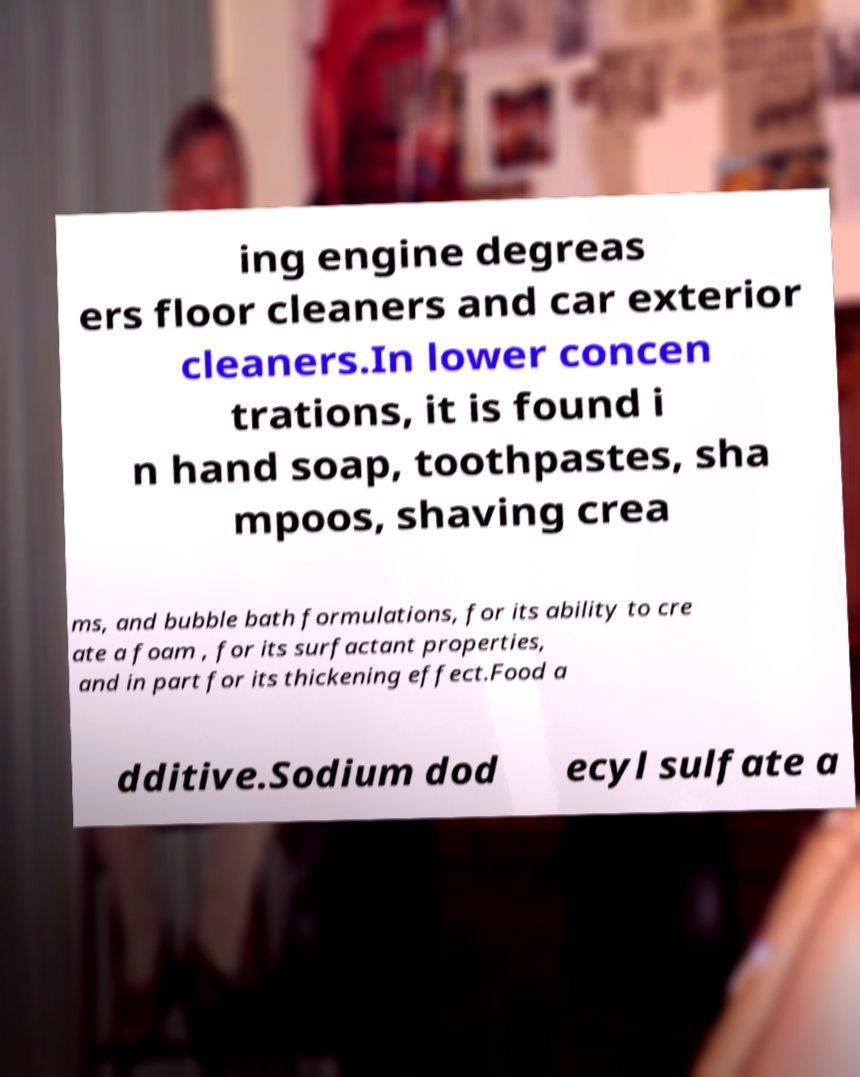Can you accurately transcribe the text from the provided image for me? ing engine degreas ers floor cleaners and car exterior cleaners.In lower concen trations, it is found i n hand soap, toothpastes, sha mpoos, shaving crea ms, and bubble bath formulations, for its ability to cre ate a foam , for its surfactant properties, and in part for its thickening effect.Food a dditive.Sodium dod ecyl sulfate a 